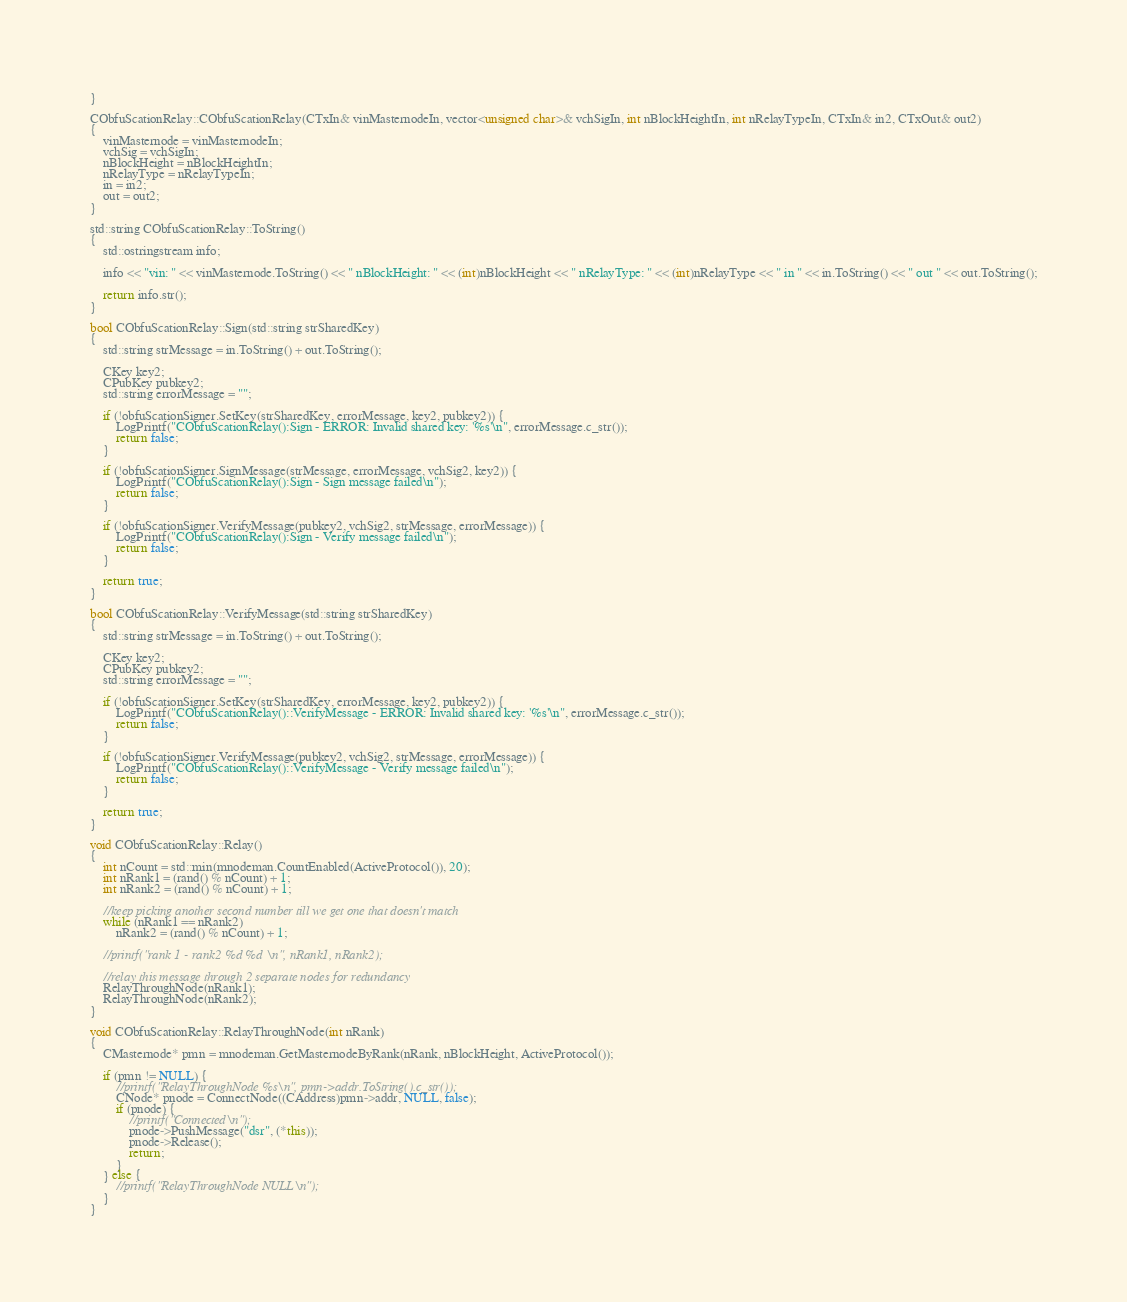<code> <loc_0><loc_0><loc_500><loc_500><_C++_>}

CObfuScationRelay::CObfuScationRelay(CTxIn& vinMasternodeIn, vector<unsigned char>& vchSigIn, int nBlockHeightIn, int nRelayTypeIn, CTxIn& in2, CTxOut& out2)
{
    vinMasternode = vinMasternodeIn;
    vchSig = vchSigIn;
    nBlockHeight = nBlockHeightIn;
    nRelayType = nRelayTypeIn;
    in = in2;
    out = out2;
}

std::string CObfuScationRelay::ToString()
{
    std::ostringstream info;

    info << "vin: " << vinMasternode.ToString() << " nBlockHeight: " << (int)nBlockHeight << " nRelayType: " << (int)nRelayType << " in " << in.ToString() << " out " << out.ToString();

    return info.str();
}

bool CObfuScationRelay::Sign(std::string strSharedKey)
{
    std::string strMessage = in.ToString() + out.ToString();

    CKey key2;
    CPubKey pubkey2;
    std::string errorMessage = "";

    if (!obfuScationSigner.SetKey(strSharedKey, errorMessage, key2, pubkey2)) {
        LogPrintf("CObfuScationRelay():Sign - ERROR: Invalid shared key: '%s'\n", errorMessage.c_str());
        return false;
    }

    if (!obfuScationSigner.SignMessage(strMessage, errorMessage, vchSig2, key2)) {
        LogPrintf("CObfuScationRelay():Sign - Sign message failed\n");
        return false;
    }

    if (!obfuScationSigner.VerifyMessage(pubkey2, vchSig2, strMessage, errorMessage)) {
        LogPrintf("CObfuScationRelay():Sign - Verify message failed\n");
        return false;
    }

    return true;
}

bool CObfuScationRelay::VerifyMessage(std::string strSharedKey)
{
    std::string strMessage = in.ToString() + out.ToString();

    CKey key2;
    CPubKey pubkey2;
    std::string errorMessage = "";

    if (!obfuScationSigner.SetKey(strSharedKey, errorMessage, key2, pubkey2)) {
        LogPrintf("CObfuScationRelay()::VerifyMessage - ERROR: Invalid shared key: '%s'\n", errorMessage.c_str());
        return false;
    }

    if (!obfuScationSigner.VerifyMessage(pubkey2, vchSig2, strMessage, errorMessage)) {
        LogPrintf("CObfuScationRelay()::VerifyMessage - Verify message failed\n");
        return false;
    }

    return true;
}

void CObfuScationRelay::Relay()
{
    int nCount = std::min(mnodeman.CountEnabled(ActiveProtocol()), 20);
    int nRank1 = (rand() % nCount) + 1;
    int nRank2 = (rand() % nCount) + 1;

    //keep picking another second number till we get one that doesn't match
    while (nRank1 == nRank2)
        nRank2 = (rand() % nCount) + 1;

    //printf("rank 1 - rank2 %d %d \n", nRank1, nRank2);

    //relay this message through 2 separate nodes for redundancy
    RelayThroughNode(nRank1);
    RelayThroughNode(nRank2);
}

void CObfuScationRelay::RelayThroughNode(int nRank)
{
    CMasternode* pmn = mnodeman.GetMasternodeByRank(nRank, nBlockHeight, ActiveProtocol());

    if (pmn != NULL) {
        //printf("RelayThroughNode %s\n", pmn->addr.ToString().c_str());
        CNode* pnode = ConnectNode((CAddress)pmn->addr, NULL, false);
        if (pnode) {
            //printf("Connected\n");
            pnode->PushMessage("dsr", (*this));
            pnode->Release();
            return;
        }
    } else {
        //printf("RelayThroughNode NULL\n");
    }
}
</code> 